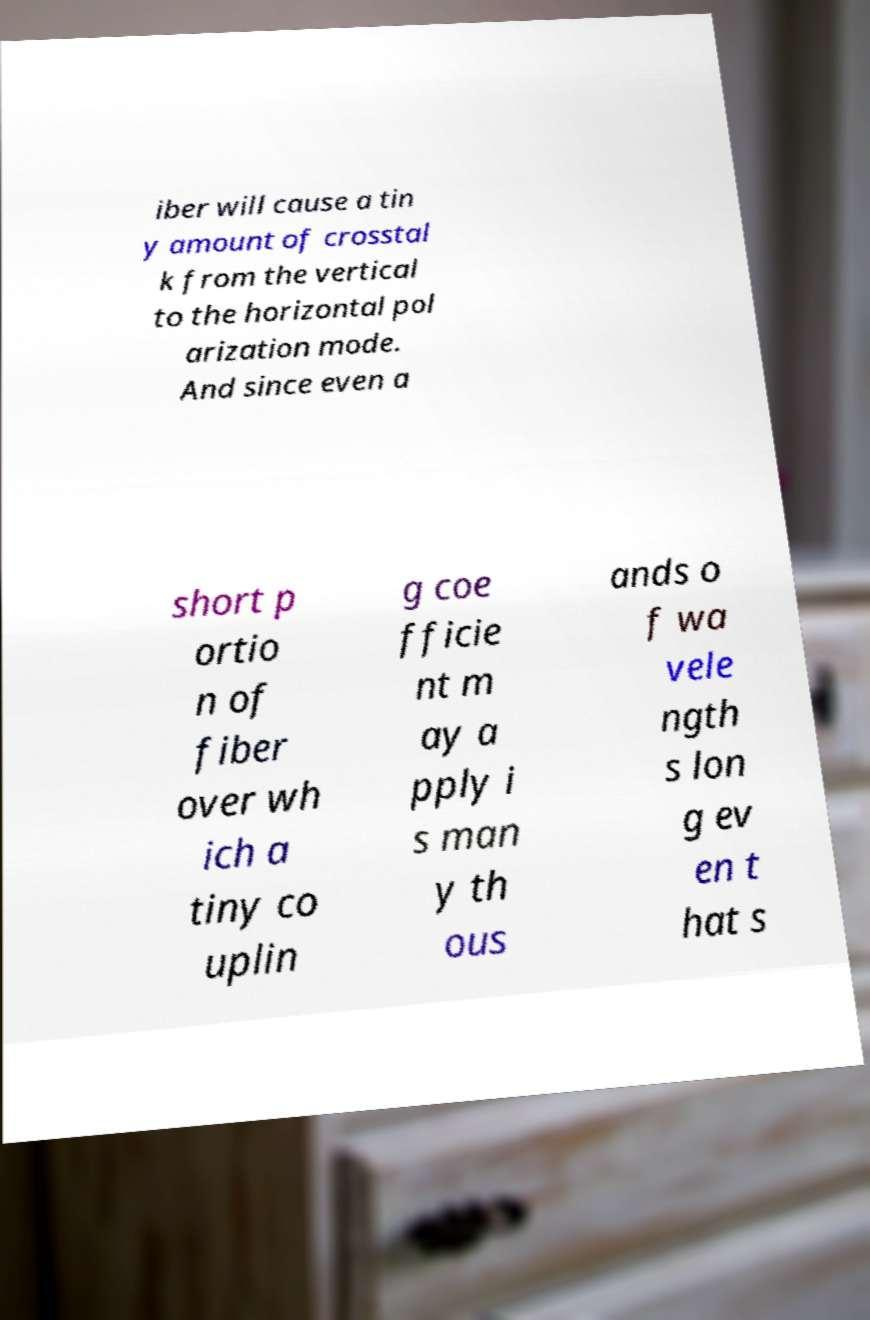Could you extract and type out the text from this image? iber will cause a tin y amount of crosstal k from the vertical to the horizontal pol arization mode. And since even a short p ortio n of fiber over wh ich a tiny co uplin g coe fficie nt m ay a pply i s man y th ous ands o f wa vele ngth s lon g ev en t hat s 